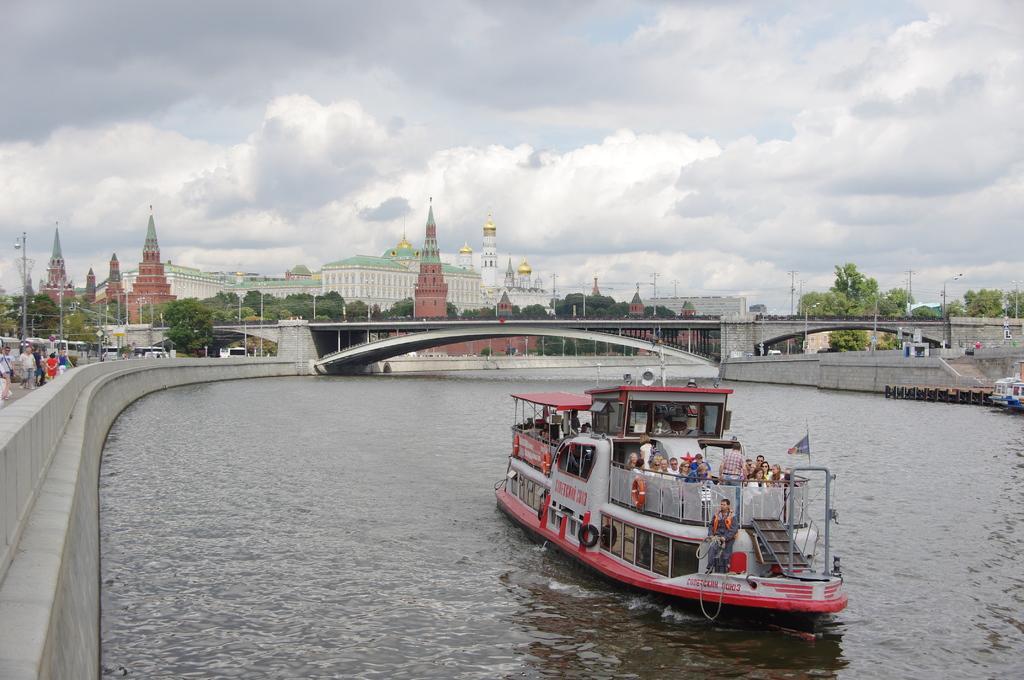Can you describe this image briefly? In this image at the bottom there is a river and also there are some boats, in the boats there are some people sitting and in the background there is a bridge, trees, poles, wires, buildings and some people and at the top of the image there is sky. 